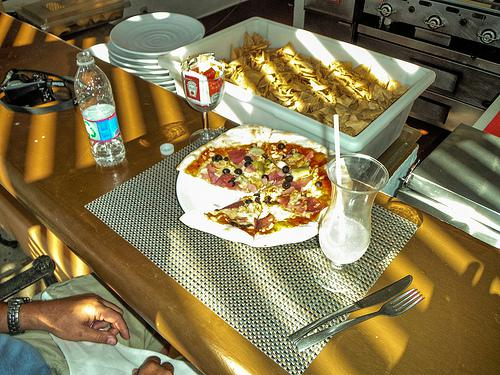Question: what is on the plate?
Choices:
A. Pizza.
B. Pasta.
C. Soap.
D. Cabbage.
Answer with the letter. Answer: A Question: what liquid is in the plastic bottle?
Choices:
A. Ketchup.
B. Water.
C. Milk.
D. Soda.
Answer with the letter. Answer: B Question: what is on the man's left wrist?
Choices:
A. Watch.
B. Bracelet.
C. String.
D. Workout band.
Answer with the letter. Answer: A 